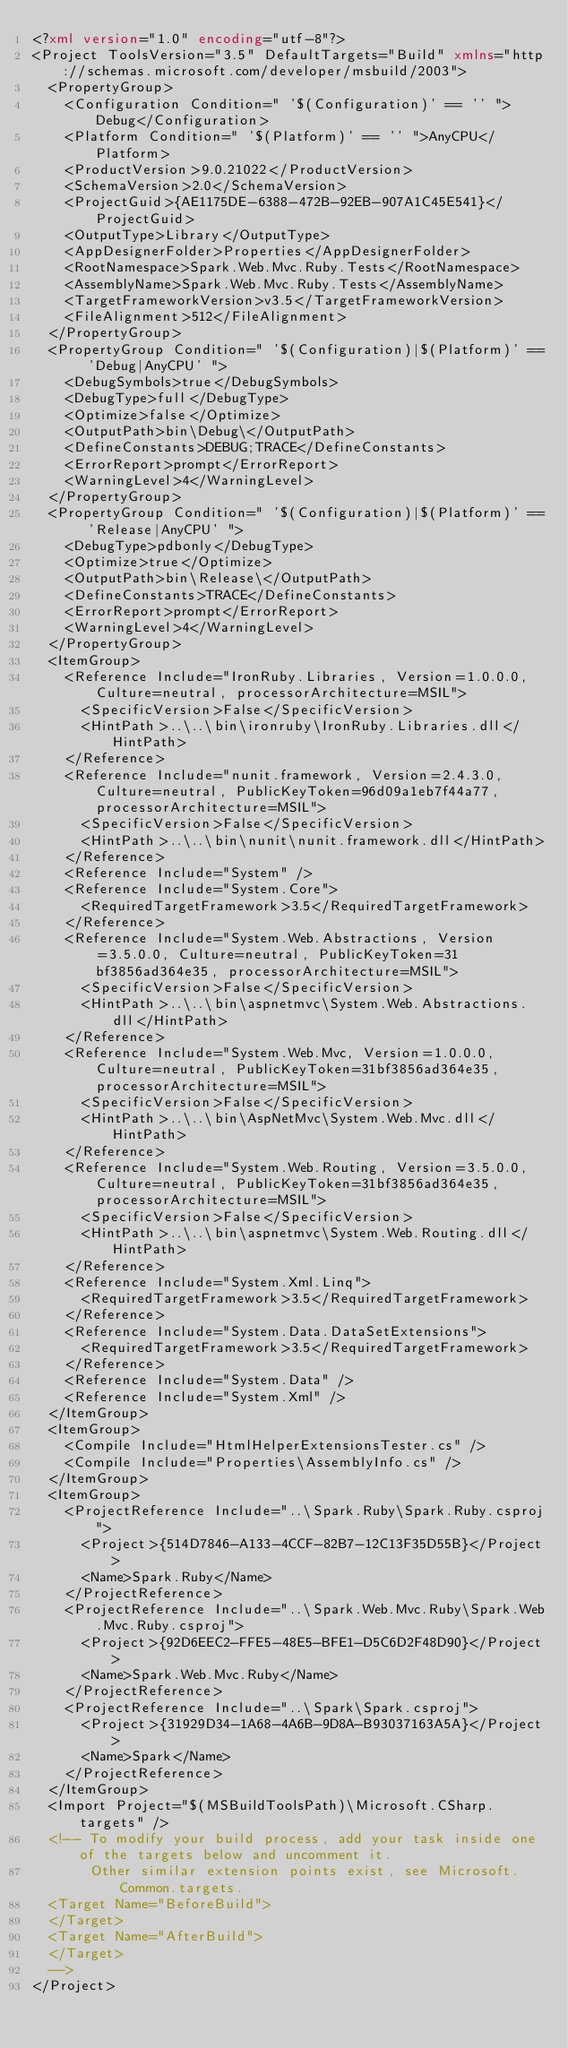Convert code to text. <code><loc_0><loc_0><loc_500><loc_500><_XML_><?xml version="1.0" encoding="utf-8"?>
<Project ToolsVersion="3.5" DefaultTargets="Build" xmlns="http://schemas.microsoft.com/developer/msbuild/2003">
  <PropertyGroup>
    <Configuration Condition=" '$(Configuration)' == '' ">Debug</Configuration>
    <Platform Condition=" '$(Platform)' == '' ">AnyCPU</Platform>
    <ProductVersion>9.0.21022</ProductVersion>
    <SchemaVersion>2.0</SchemaVersion>
    <ProjectGuid>{AE1175DE-6388-472B-92EB-907A1C45E541}</ProjectGuid>
    <OutputType>Library</OutputType>
    <AppDesignerFolder>Properties</AppDesignerFolder>
    <RootNamespace>Spark.Web.Mvc.Ruby.Tests</RootNamespace>
    <AssemblyName>Spark.Web.Mvc.Ruby.Tests</AssemblyName>
    <TargetFrameworkVersion>v3.5</TargetFrameworkVersion>
    <FileAlignment>512</FileAlignment>
  </PropertyGroup>
  <PropertyGroup Condition=" '$(Configuration)|$(Platform)' == 'Debug|AnyCPU' ">
    <DebugSymbols>true</DebugSymbols>
    <DebugType>full</DebugType>
    <Optimize>false</Optimize>
    <OutputPath>bin\Debug\</OutputPath>
    <DefineConstants>DEBUG;TRACE</DefineConstants>
    <ErrorReport>prompt</ErrorReport>
    <WarningLevel>4</WarningLevel>
  </PropertyGroup>
  <PropertyGroup Condition=" '$(Configuration)|$(Platform)' == 'Release|AnyCPU' ">
    <DebugType>pdbonly</DebugType>
    <Optimize>true</Optimize>
    <OutputPath>bin\Release\</OutputPath>
    <DefineConstants>TRACE</DefineConstants>
    <ErrorReport>prompt</ErrorReport>
    <WarningLevel>4</WarningLevel>
  </PropertyGroup>
  <ItemGroup>
    <Reference Include="IronRuby.Libraries, Version=1.0.0.0, Culture=neutral, processorArchitecture=MSIL">
      <SpecificVersion>False</SpecificVersion>
      <HintPath>..\..\bin\ironruby\IronRuby.Libraries.dll</HintPath>
    </Reference>
    <Reference Include="nunit.framework, Version=2.4.3.0, Culture=neutral, PublicKeyToken=96d09a1eb7f44a77, processorArchitecture=MSIL">
      <SpecificVersion>False</SpecificVersion>
      <HintPath>..\..\bin\nunit\nunit.framework.dll</HintPath>
    </Reference>
    <Reference Include="System" />
    <Reference Include="System.Core">
      <RequiredTargetFramework>3.5</RequiredTargetFramework>
    </Reference>
    <Reference Include="System.Web.Abstractions, Version=3.5.0.0, Culture=neutral, PublicKeyToken=31bf3856ad364e35, processorArchitecture=MSIL">
      <SpecificVersion>False</SpecificVersion>
      <HintPath>..\..\bin\aspnetmvc\System.Web.Abstractions.dll</HintPath>
    </Reference>
    <Reference Include="System.Web.Mvc, Version=1.0.0.0, Culture=neutral, PublicKeyToken=31bf3856ad364e35, processorArchitecture=MSIL">
      <SpecificVersion>False</SpecificVersion>
      <HintPath>..\..\bin\AspNetMvc\System.Web.Mvc.dll</HintPath>
    </Reference>
    <Reference Include="System.Web.Routing, Version=3.5.0.0, Culture=neutral, PublicKeyToken=31bf3856ad364e35, processorArchitecture=MSIL">
      <SpecificVersion>False</SpecificVersion>
      <HintPath>..\..\bin\aspnetmvc\System.Web.Routing.dll</HintPath>
    </Reference>
    <Reference Include="System.Xml.Linq">
      <RequiredTargetFramework>3.5</RequiredTargetFramework>
    </Reference>
    <Reference Include="System.Data.DataSetExtensions">
      <RequiredTargetFramework>3.5</RequiredTargetFramework>
    </Reference>
    <Reference Include="System.Data" />
    <Reference Include="System.Xml" />
  </ItemGroup>
  <ItemGroup>
    <Compile Include="HtmlHelperExtensionsTester.cs" />
    <Compile Include="Properties\AssemblyInfo.cs" />
  </ItemGroup>
  <ItemGroup>
    <ProjectReference Include="..\Spark.Ruby\Spark.Ruby.csproj">
      <Project>{514D7846-A133-4CCF-82B7-12C13F35D55B}</Project>
      <Name>Spark.Ruby</Name>
    </ProjectReference>
    <ProjectReference Include="..\Spark.Web.Mvc.Ruby\Spark.Web.Mvc.Ruby.csproj">
      <Project>{92D6EEC2-FFE5-48E5-BFE1-D5C6D2F48D90}</Project>
      <Name>Spark.Web.Mvc.Ruby</Name>
    </ProjectReference>
    <ProjectReference Include="..\Spark\Spark.csproj">
      <Project>{31929D34-1A68-4A6B-9D8A-B93037163A5A}</Project>
      <Name>Spark</Name>
    </ProjectReference>
  </ItemGroup>
  <Import Project="$(MSBuildToolsPath)\Microsoft.CSharp.targets" />
  <!-- To modify your build process, add your task inside one of the targets below and uncomment it. 
       Other similar extension points exist, see Microsoft.Common.targets.
  <Target Name="BeforeBuild">
  </Target>
  <Target Name="AfterBuild">
  </Target>
  -->
</Project></code> 